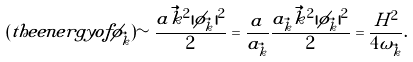<formula> <loc_0><loc_0><loc_500><loc_500>( t h e e n e r g y o f \phi _ { \vec { k } } ) \sim \frac { a \vec { k } ^ { 2 } | \phi _ { \vec { k } } | ^ { 2 } } { 2 } = \frac { a } { a _ { \vec { k } } } \frac { a _ { \vec { k } } \vec { k } ^ { 2 } | \phi _ { \vec { k } } | ^ { 2 } } { 2 } = \frac { H ^ { 2 } } { 4 \omega _ { \vec { k } } } .</formula> 